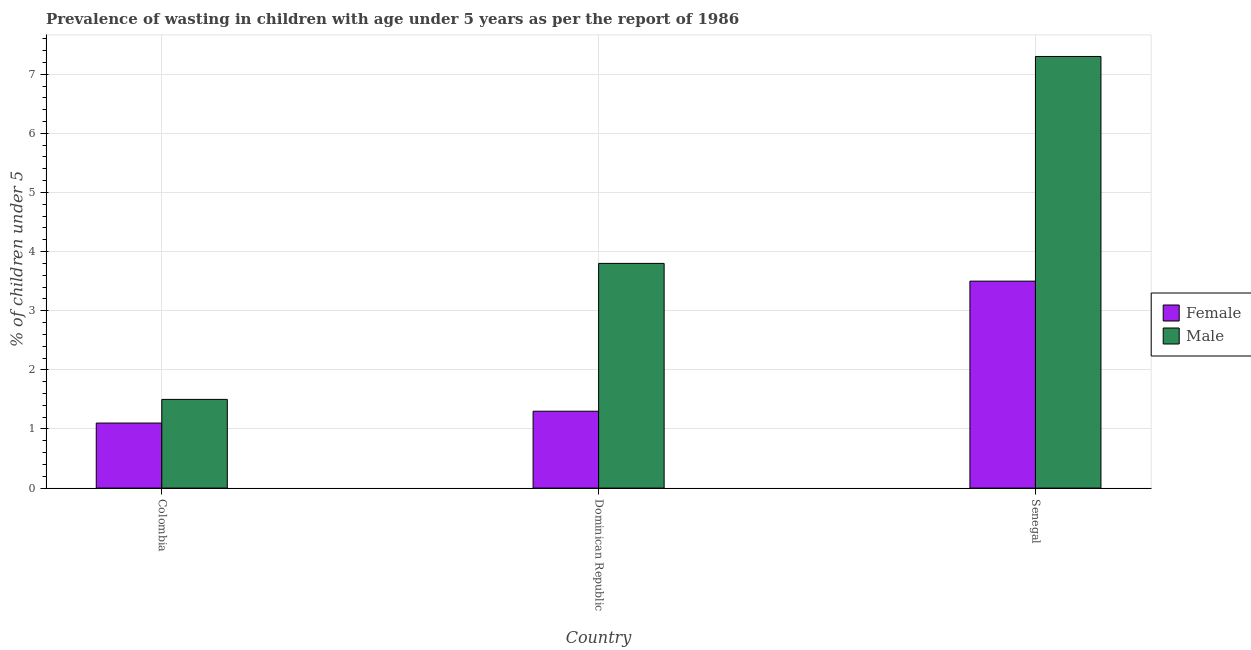How many different coloured bars are there?
Offer a very short reply. 2. How many bars are there on the 2nd tick from the right?
Provide a short and direct response. 2. What is the label of the 2nd group of bars from the left?
Provide a short and direct response. Dominican Republic. What is the percentage of undernourished male children in Dominican Republic?
Make the answer very short. 3.8. Across all countries, what is the minimum percentage of undernourished female children?
Provide a succinct answer. 1.1. In which country was the percentage of undernourished female children maximum?
Offer a terse response. Senegal. In which country was the percentage of undernourished female children minimum?
Provide a short and direct response. Colombia. What is the total percentage of undernourished male children in the graph?
Give a very brief answer. 12.6. What is the difference between the percentage of undernourished female children in Dominican Republic and that in Senegal?
Offer a very short reply. -2.2. What is the difference between the percentage of undernourished male children in Senegal and the percentage of undernourished female children in Colombia?
Keep it short and to the point. 6.2. What is the average percentage of undernourished male children per country?
Your response must be concise. 4.2. What is the difference between the percentage of undernourished female children and percentage of undernourished male children in Dominican Republic?
Provide a succinct answer. -2.5. In how many countries, is the percentage of undernourished female children greater than 3.6 %?
Keep it short and to the point. 0. What is the ratio of the percentage of undernourished male children in Colombia to that in Dominican Republic?
Your response must be concise. 0.39. Is the percentage of undernourished male children in Colombia less than that in Senegal?
Offer a very short reply. Yes. What is the difference between the highest and the second highest percentage of undernourished female children?
Make the answer very short. 2.2. What is the difference between the highest and the lowest percentage of undernourished male children?
Make the answer very short. 5.8. How many bars are there?
Provide a succinct answer. 6. How many countries are there in the graph?
Provide a short and direct response. 3. Are the values on the major ticks of Y-axis written in scientific E-notation?
Your answer should be compact. No. How are the legend labels stacked?
Offer a terse response. Vertical. What is the title of the graph?
Offer a very short reply. Prevalence of wasting in children with age under 5 years as per the report of 1986. What is the label or title of the Y-axis?
Ensure brevity in your answer.   % of children under 5. What is the  % of children under 5 of Female in Colombia?
Ensure brevity in your answer.  1.1. What is the  % of children under 5 of Male in Colombia?
Give a very brief answer. 1.5. What is the  % of children under 5 of Female in Dominican Republic?
Give a very brief answer. 1.3. What is the  % of children under 5 of Male in Dominican Republic?
Keep it short and to the point. 3.8. What is the  % of children under 5 of Male in Senegal?
Offer a terse response. 7.3. Across all countries, what is the maximum  % of children under 5 of Female?
Make the answer very short. 3.5. Across all countries, what is the maximum  % of children under 5 of Male?
Your answer should be very brief. 7.3. Across all countries, what is the minimum  % of children under 5 in Female?
Your answer should be very brief. 1.1. What is the total  % of children under 5 in Female in the graph?
Provide a succinct answer. 5.9. What is the difference between the  % of children under 5 in Female in Colombia and the  % of children under 5 in Male in Dominican Republic?
Your answer should be very brief. -2.7. What is the difference between the  % of children under 5 of Female in Colombia and the  % of children under 5 of Male in Senegal?
Make the answer very short. -6.2. What is the difference between the  % of children under 5 in Female in Dominican Republic and the  % of children under 5 in Male in Senegal?
Your answer should be compact. -6. What is the average  % of children under 5 of Female per country?
Provide a succinct answer. 1.97. What is the difference between the  % of children under 5 in Female and  % of children under 5 in Male in Senegal?
Keep it short and to the point. -3.8. What is the ratio of the  % of children under 5 of Female in Colombia to that in Dominican Republic?
Make the answer very short. 0.85. What is the ratio of the  % of children under 5 of Male in Colombia to that in Dominican Republic?
Make the answer very short. 0.39. What is the ratio of the  % of children under 5 of Female in Colombia to that in Senegal?
Provide a short and direct response. 0.31. What is the ratio of the  % of children under 5 of Male in Colombia to that in Senegal?
Your response must be concise. 0.21. What is the ratio of the  % of children under 5 in Female in Dominican Republic to that in Senegal?
Provide a short and direct response. 0.37. What is the ratio of the  % of children under 5 in Male in Dominican Republic to that in Senegal?
Your answer should be very brief. 0.52. What is the difference between the highest and the lowest  % of children under 5 in Male?
Your answer should be very brief. 5.8. 